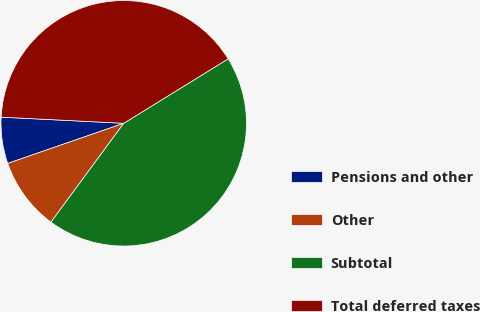<chart> <loc_0><loc_0><loc_500><loc_500><pie_chart><fcel>Pensions and other<fcel>Other<fcel>Subtotal<fcel>Total deferred taxes<nl><fcel>6.1%<fcel>9.6%<fcel>43.9%<fcel>40.4%<nl></chart> 